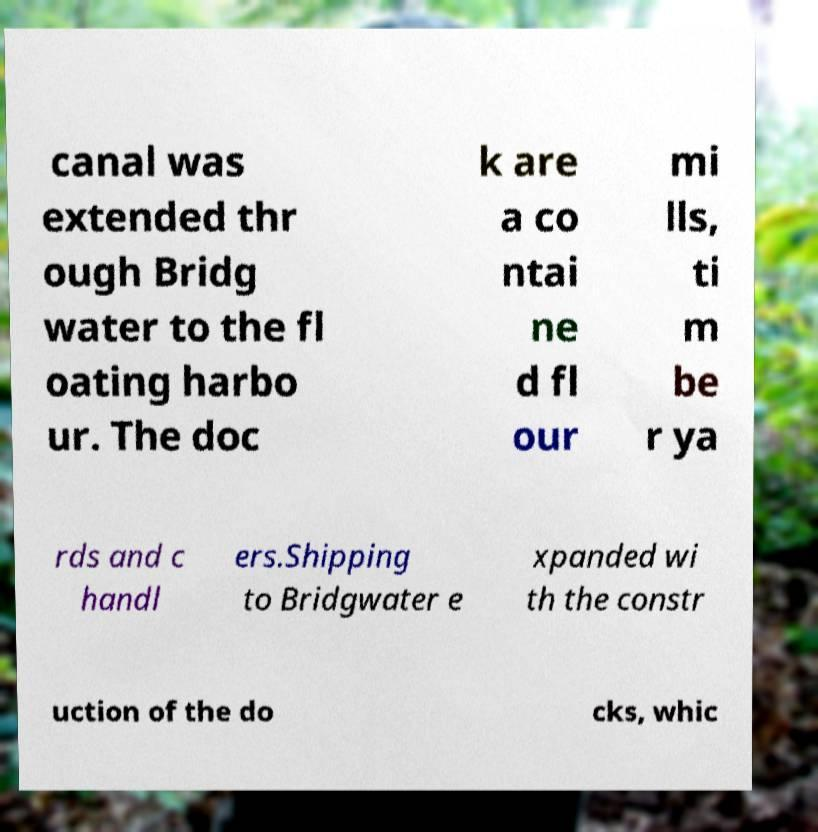Please identify and transcribe the text found in this image. canal was extended thr ough Bridg water to the fl oating harbo ur. The doc k are a co ntai ne d fl our mi lls, ti m be r ya rds and c handl ers.Shipping to Bridgwater e xpanded wi th the constr uction of the do cks, whic 